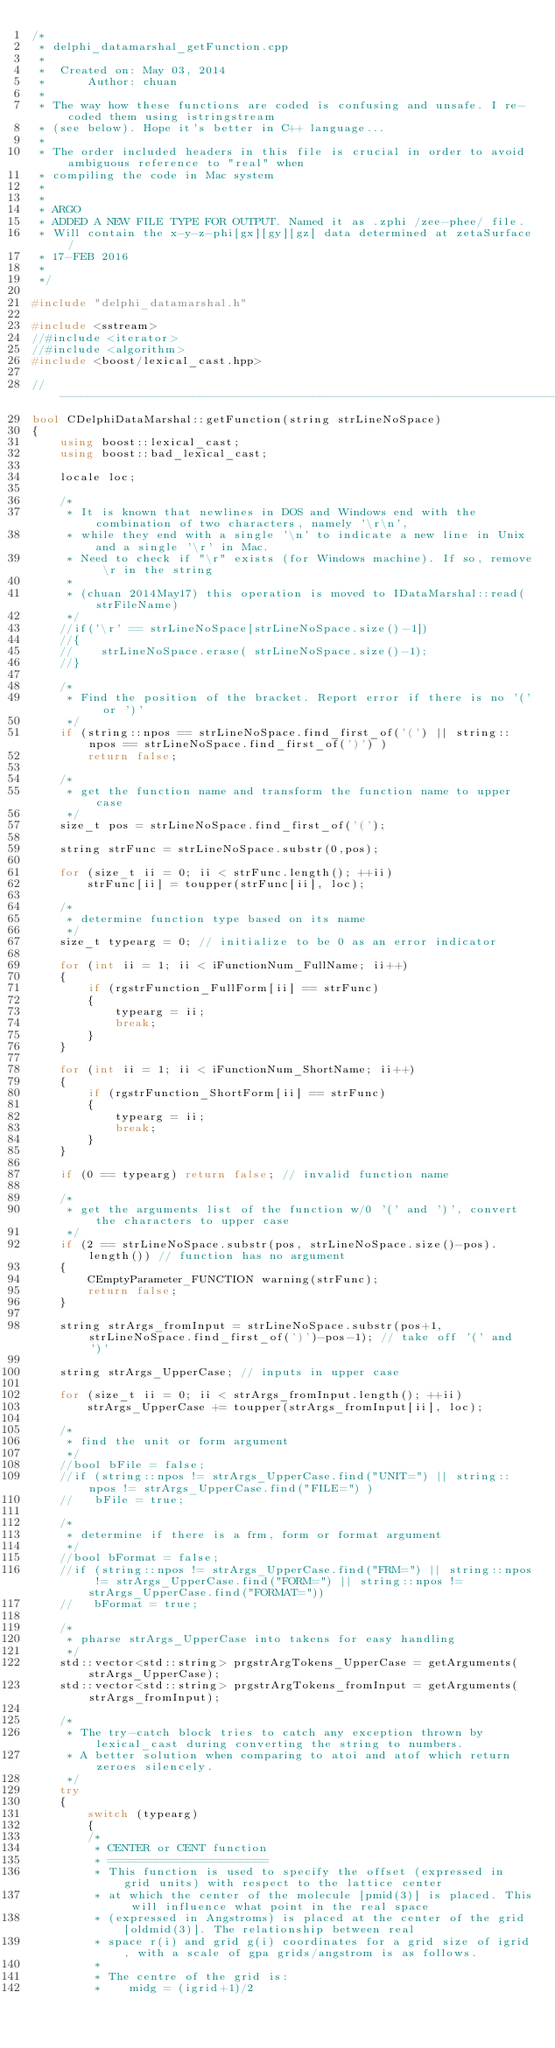<code> <loc_0><loc_0><loc_500><loc_500><_C++_>/*
 * delphi_datamarshal_getFunction.cpp
 *
 *  Created on: May 03, 2014
 *      Author: chuan
 *
 * The way how these functions are coded is confusing and unsafe. I re-coded them using istringstream
 * (see below). Hope it's better in C++ language...
 *
 * The order included headers in this file is crucial in order to avoid ambiguous reference to "real" when
 * compiling the code in Mac system
 *
 *
 * ARGO
 * ADDED A NEW FILE TYPE FOR OUTPUT. Named it as .zphi /zee-phee/ file.
 * Will contain the x-y-z-phi[gx][gy][gz] data determined at zetaSurface/
 * 17-FEB 2016
 *
 */

#include "delphi_datamarshal.h"

#include <sstream>
//#include <iterator>
//#include <algorithm>
#include <boost/lexical_cast.hpp>

//-----------------------------------------------------------------------//
bool CDelphiDataMarshal::getFunction(string strLineNoSpace)
{
    using boost::lexical_cast;
    using boost::bad_lexical_cast;

    locale loc;

    /*
     * It is known that newlines in DOS and Windows end with the combination of two characters, namely '\r\n',
     * while they end with a single '\n' to indicate a new line in Unix and a single '\r' in Mac.
     * Need to check if "\r" exists (for Windows machine). If so, remove \r in the string
     *
     * (chuan 2014May17) this operation is moved to IDataMarshal::read(strFileName)
     */
    //if('\r' == strLineNoSpace[strLineNoSpace.size()-1])
    //{
    //    strLineNoSpace.erase( strLineNoSpace.size()-1);
    //}

    /*
     * Find the position of the bracket. Report error if there is no '(' or ')'
     */
    if (string::npos == strLineNoSpace.find_first_of('(') || string::npos == strLineNoSpace.find_first_of(')') )
        return false;

    /*
     * get the function name and transform the function name to upper case
     */
    size_t pos = strLineNoSpace.find_first_of('(');

    string strFunc = strLineNoSpace.substr(0,pos);

    for (size_t ii = 0; ii < strFunc.length(); ++ii)
        strFunc[ii] = toupper(strFunc[ii], loc);

    /*
     * determine function type based on its name
     */
    size_t typearg = 0; // initialize to be 0 as an error indicator

    for (int ii = 1; ii < iFunctionNum_FullName; ii++)
    {
        if (rgstrFunction_FullForm[ii] == strFunc)
        {
            typearg = ii;
            break;
        }
    }

    for (int ii = 1; ii < iFunctionNum_ShortName; ii++)
    {
        if (rgstrFunction_ShortForm[ii] == strFunc)
        {
            typearg = ii;
            break;
        }
    }

    if (0 == typearg) return false; // invalid function name

    /*
     * get the arguments list of the function w/0 '(' and ')', convert the characters to upper case
     */
    if (2 == strLineNoSpace.substr(pos, strLineNoSpace.size()-pos).length()) // function has no argument
    {
        CEmptyParameter_FUNCTION warning(strFunc);
        return false;
    }

    string strArgs_fromInput = strLineNoSpace.substr(pos+1, strLineNoSpace.find_first_of(')')-pos-1); // take off '(' and ')'

    string strArgs_UpperCase; // inputs in upper case

    for (size_t ii = 0; ii < strArgs_fromInput.length(); ++ii)
        strArgs_UpperCase += toupper(strArgs_fromInput[ii], loc);

    /*
     * find the unit or form argument
     */
    //bool bFile = false;
    //if (string::npos != strArgs_UpperCase.find("UNIT=") || string::npos != strArgs_UpperCase.find("FILE=") )
    //   bFile = true;

    /*
     * determine if there is a frm, form or format argument
     */
    //bool bFormat = false;
    //if (string::npos != strArgs_UpperCase.find("FRM=") || string::npos != strArgs_UpperCase.find("FORM=") || string::npos != strArgs_UpperCase.find("FORMAT="))
    //   bFormat = true;

    /*
     * pharse strArgs_UpperCase into takens for easy handling
     */
    std::vector<std::string> prgstrArgTokens_UpperCase = getArguments(strArgs_UpperCase);
    std::vector<std::string> prgstrArgTokens_fromInput = getArguments(strArgs_fromInput);

    /*
     * The try-catch block tries to catch any exception thrown by lexical_cast during converting the string to numbers.
     * A better solution when comparing to atoi and atof which return zeroes silencely.
     */
    try
    {
        switch (typearg)
        {
        /*
         * CENTER or CENT function
         * =======================
         * This function is used to specify the offset (expressed in grid units) with respect to the lattice center
         * at which the center of the molecule [pmid(3)] is placed. This will influence what point in the real space
         * (expressed in Angstroms) is placed at the center of the grid [oldmid(3)]. The relationship between real
         * space r(i) and grid g(i) coordinates for a grid size of igrid, with a scale of gpa grids/angstrom is as follows.
         *
         * The centre of the grid is:
         *    midg = (igrid+1)/2</code> 